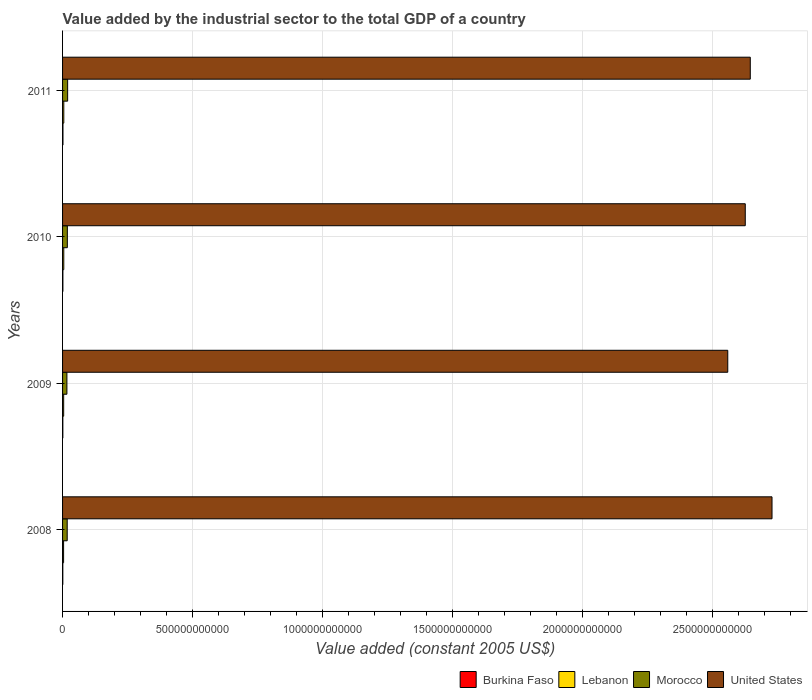How many different coloured bars are there?
Offer a terse response. 4. How many groups of bars are there?
Your answer should be very brief. 4. How many bars are there on the 3rd tick from the top?
Keep it short and to the point. 4. What is the label of the 4th group of bars from the top?
Your response must be concise. 2008. What is the value added by the industrial sector in Morocco in 2009?
Your answer should be compact. 1.67e+1. Across all years, what is the maximum value added by the industrial sector in Burkina Faso?
Keep it short and to the point. 1.52e+09. Across all years, what is the minimum value added by the industrial sector in United States?
Offer a terse response. 2.56e+12. In which year was the value added by the industrial sector in Burkina Faso maximum?
Your answer should be very brief. 2011. What is the total value added by the industrial sector in United States in the graph?
Your response must be concise. 1.06e+13. What is the difference between the value added by the industrial sector in Lebanon in 2008 and that in 2009?
Your response must be concise. -3.20e+08. What is the difference between the value added by the industrial sector in Lebanon in 2010 and the value added by the industrial sector in Burkina Faso in 2011?
Your answer should be compact. 3.13e+09. What is the average value added by the industrial sector in Lebanon per year?
Your answer should be very brief. 4.40e+09. In the year 2008, what is the difference between the value added by the industrial sector in United States and value added by the industrial sector in Burkina Faso?
Ensure brevity in your answer.  2.73e+12. What is the ratio of the value added by the industrial sector in Burkina Faso in 2008 to that in 2010?
Give a very brief answer. 0.78. Is the value added by the industrial sector in United States in 2008 less than that in 2010?
Your answer should be very brief. No. Is the difference between the value added by the industrial sector in United States in 2008 and 2010 greater than the difference between the value added by the industrial sector in Burkina Faso in 2008 and 2010?
Your answer should be compact. Yes. What is the difference between the highest and the second highest value added by the industrial sector in Burkina Faso?
Provide a succinct answer. 2.94e+08. What is the difference between the highest and the lowest value added by the industrial sector in United States?
Offer a terse response. 1.70e+11. Is the sum of the value added by the industrial sector in Morocco in 2008 and 2009 greater than the maximum value added by the industrial sector in Burkina Faso across all years?
Your answer should be very brief. Yes. What does the 3rd bar from the top in 2010 represents?
Ensure brevity in your answer.  Lebanon. What does the 1st bar from the bottom in 2010 represents?
Provide a short and direct response. Burkina Faso. How many years are there in the graph?
Give a very brief answer. 4. What is the difference between two consecutive major ticks on the X-axis?
Provide a short and direct response. 5.00e+11. Does the graph contain grids?
Keep it short and to the point. Yes. Where does the legend appear in the graph?
Give a very brief answer. Bottom right. What is the title of the graph?
Your response must be concise. Value added by the industrial sector to the total GDP of a country. Does "Korea (Democratic)" appear as one of the legend labels in the graph?
Your response must be concise. No. What is the label or title of the X-axis?
Make the answer very short. Value added (constant 2005 US$). What is the Value added (constant 2005 US$) in Burkina Faso in 2008?
Your answer should be very brief. 9.61e+08. What is the Value added (constant 2005 US$) in Lebanon in 2008?
Your response must be concise. 3.95e+09. What is the Value added (constant 2005 US$) of Morocco in 2008?
Make the answer very short. 1.78e+1. What is the Value added (constant 2005 US$) in United States in 2008?
Offer a terse response. 2.73e+12. What is the Value added (constant 2005 US$) of Burkina Faso in 2009?
Keep it short and to the point. 1.08e+09. What is the Value added (constant 2005 US$) in Lebanon in 2009?
Offer a terse response. 4.27e+09. What is the Value added (constant 2005 US$) of Morocco in 2009?
Make the answer very short. 1.67e+1. What is the Value added (constant 2005 US$) in United States in 2009?
Ensure brevity in your answer.  2.56e+12. What is the Value added (constant 2005 US$) in Burkina Faso in 2010?
Your answer should be very brief. 1.23e+09. What is the Value added (constant 2005 US$) in Lebanon in 2010?
Keep it short and to the point. 4.65e+09. What is the Value added (constant 2005 US$) of Morocco in 2010?
Offer a terse response. 1.84e+1. What is the Value added (constant 2005 US$) of United States in 2010?
Offer a very short reply. 2.62e+12. What is the Value added (constant 2005 US$) in Burkina Faso in 2011?
Ensure brevity in your answer.  1.52e+09. What is the Value added (constant 2005 US$) in Lebanon in 2011?
Make the answer very short. 4.75e+09. What is the Value added (constant 2005 US$) in Morocco in 2011?
Make the answer very short. 1.95e+1. What is the Value added (constant 2005 US$) of United States in 2011?
Make the answer very short. 2.64e+12. Across all years, what is the maximum Value added (constant 2005 US$) of Burkina Faso?
Provide a succinct answer. 1.52e+09. Across all years, what is the maximum Value added (constant 2005 US$) of Lebanon?
Provide a short and direct response. 4.75e+09. Across all years, what is the maximum Value added (constant 2005 US$) in Morocco?
Give a very brief answer. 1.95e+1. Across all years, what is the maximum Value added (constant 2005 US$) of United States?
Ensure brevity in your answer.  2.73e+12. Across all years, what is the minimum Value added (constant 2005 US$) of Burkina Faso?
Offer a very short reply. 9.61e+08. Across all years, what is the minimum Value added (constant 2005 US$) in Lebanon?
Give a very brief answer. 3.95e+09. Across all years, what is the minimum Value added (constant 2005 US$) of Morocco?
Provide a short and direct response. 1.67e+1. Across all years, what is the minimum Value added (constant 2005 US$) in United States?
Offer a very short reply. 2.56e+12. What is the total Value added (constant 2005 US$) in Burkina Faso in the graph?
Your answer should be very brief. 4.80e+09. What is the total Value added (constant 2005 US$) in Lebanon in the graph?
Your response must be concise. 1.76e+1. What is the total Value added (constant 2005 US$) in Morocco in the graph?
Keep it short and to the point. 7.24e+1. What is the total Value added (constant 2005 US$) in United States in the graph?
Ensure brevity in your answer.  1.06e+13. What is the difference between the Value added (constant 2005 US$) in Burkina Faso in 2008 and that in 2009?
Give a very brief answer. -1.23e+08. What is the difference between the Value added (constant 2005 US$) of Lebanon in 2008 and that in 2009?
Provide a succinct answer. -3.20e+08. What is the difference between the Value added (constant 2005 US$) of Morocco in 2008 and that in 2009?
Offer a terse response. 1.17e+09. What is the difference between the Value added (constant 2005 US$) in United States in 2008 and that in 2009?
Provide a short and direct response. 1.70e+11. What is the difference between the Value added (constant 2005 US$) of Burkina Faso in 2008 and that in 2010?
Keep it short and to the point. -2.68e+08. What is the difference between the Value added (constant 2005 US$) of Lebanon in 2008 and that in 2010?
Provide a succinct answer. -7.02e+08. What is the difference between the Value added (constant 2005 US$) in Morocco in 2008 and that in 2010?
Ensure brevity in your answer.  -5.33e+08. What is the difference between the Value added (constant 2005 US$) in United States in 2008 and that in 2010?
Your answer should be compact. 1.03e+11. What is the difference between the Value added (constant 2005 US$) of Burkina Faso in 2008 and that in 2011?
Offer a very short reply. -5.62e+08. What is the difference between the Value added (constant 2005 US$) in Lebanon in 2008 and that in 2011?
Keep it short and to the point. -7.96e+08. What is the difference between the Value added (constant 2005 US$) of Morocco in 2008 and that in 2011?
Provide a succinct answer. -1.69e+09. What is the difference between the Value added (constant 2005 US$) of United States in 2008 and that in 2011?
Provide a succinct answer. 8.36e+1. What is the difference between the Value added (constant 2005 US$) in Burkina Faso in 2009 and that in 2010?
Make the answer very short. -1.45e+08. What is the difference between the Value added (constant 2005 US$) of Lebanon in 2009 and that in 2010?
Your answer should be compact. -3.82e+08. What is the difference between the Value added (constant 2005 US$) of Morocco in 2009 and that in 2010?
Offer a terse response. -1.71e+09. What is the difference between the Value added (constant 2005 US$) in United States in 2009 and that in 2010?
Provide a short and direct response. -6.73e+1. What is the difference between the Value added (constant 2005 US$) in Burkina Faso in 2009 and that in 2011?
Give a very brief answer. -4.38e+08. What is the difference between the Value added (constant 2005 US$) of Lebanon in 2009 and that in 2011?
Your answer should be compact. -4.75e+08. What is the difference between the Value added (constant 2005 US$) in Morocco in 2009 and that in 2011?
Your response must be concise. -2.86e+09. What is the difference between the Value added (constant 2005 US$) of United States in 2009 and that in 2011?
Provide a short and direct response. -8.66e+1. What is the difference between the Value added (constant 2005 US$) of Burkina Faso in 2010 and that in 2011?
Offer a very short reply. -2.94e+08. What is the difference between the Value added (constant 2005 US$) of Lebanon in 2010 and that in 2011?
Your answer should be very brief. -9.35e+07. What is the difference between the Value added (constant 2005 US$) in Morocco in 2010 and that in 2011?
Provide a short and direct response. -1.16e+09. What is the difference between the Value added (constant 2005 US$) of United States in 2010 and that in 2011?
Provide a succinct answer. -1.93e+1. What is the difference between the Value added (constant 2005 US$) of Burkina Faso in 2008 and the Value added (constant 2005 US$) of Lebanon in 2009?
Give a very brief answer. -3.31e+09. What is the difference between the Value added (constant 2005 US$) in Burkina Faso in 2008 and the Value added (constant 2005 US$) in Morocco in 2009?
Keep it short and to the point. -1.57e+1. What is the difference between the Value added (constant 2005 US$) of Burkina Faso in 2008 and the Value added (constant 2005 US$) of United States in 2009?
Your response must be concise. -2.56e+12. What is the difference between the Value added (constant 2005 US$) of Lebanon in 2008 and the Value added (constant 2005 US$) of Morocco in 2009?
Provide a short and direct response. -1.27e+1. What is the difference between the Value added (constant 2005 US$) in Lebanon in 2008 and the Value added (constant 2005 US$) in United States in 2009?
Keep it short and to the point. -2.55e+12. What is the difference between the Value added (constant 2005 US$) in Morocco in 2008 and the Value added (constant 2005 US$) in United States in 2009?
Provide a short and direct response. -2.54e+12. What is the difference between the Value added (constant 2005 US$) of Burkina Faso in 2008 and the Value added (constant 2005 US$) of Lebanon in 2010?
Provide a short and direct response. -3.69e+09. What is the difference between the Value added (constant 2005 US$) of Burkina Faso in 2008 and the Value added (constant 2005 US$) of Morocco in 2010?
Your answer should be very brief. -1.74e+1. What is the difference between the Value added (constant 2005 US$) in Burkina Faso in 2008 and the Value added (constant 2005 US$) in United States in 2010?
Your response must be concise. -2.62e+12. What is the difference between the Value added (constant 2005 US$) of Lebanon in 2008 and the Value added (constant 2005 US$) of Morocco in 2010?
Ensure brevity in your answer.  -1.44e+1. What is the difference between the Value added (constant 2005 US$) of Lebanon in 2008 and the Value added (constant 2005 US$) of United States in 2010?
Give a very brief answer. -2.62e+12. What is the difference between the Value added (constant 2005 US$) of Morocco in 2008 and the Value added (constant 2005 US$) of United States in 2010?
Make the answer very short. -2.61e+12. What is the difference between the Value added (constant 2005 US$) in Burkina Faso in 2008 and the Value added (constant 2005 US$) in Lebanon in 2011?
Your response must be concise. -3.78e+09. What is the difference between the Value added (constant 2005 US$) of Burkina Faso in 2008 and the Value added (constant 2005 US$) of Morocco in 2011?
Offer a very short reply. -1.86e+1. What is the difference between the Value added (constant 2005 US$) in Burkina Faso in 2008 and the Value added (constant 2005 US$) in United States in 2011?
Your response must be concise. -2.64e+12. What is the difference between the Value added (constant 2005 US$) of Lebanon in 2008 and the Value added (constant 2005 US$) of Morocco in 2011?
Keep it short and to the point. -1.56e+1. What is the difference between the Value added (constant 2005 US$) of Lebanon in 2008 and the Value added (constant 2005 US$) of United States in 2011?
Offer a terse response. -2.64e+12. What is the difference between the Value added (constant 2005 US$) in Morocco in 2008 and the Value added (constant 2005 US$) in United States in 2011?
Your answer should be compact. -2.63e+12. What is the difference between the Value added (constant 2005 US$) in Burkina Faso in 2009 and the Value added (constant 2005 US$) in Lebanon in 2010?
Provide a succinct answer. -3.57e+09. What is the difference between the Value added (constant 2005 US$) in Burkina Faso in 2009 and the Value added (constant 2005 US$) in Morocco in 2010?
Ensure brevity in your answer.  -1.73e+1. What is the difference between the Value added (constant 2005 US$) in Burkina Faso in 2009 and the Value added (constant 2005 US$) in United States in 2010?
Offer a terse response. -2.62e+12. What is the difference between the Value added (constant 2005 US$) of Lebanon in 2009 and the Value added (constant 2005 US$) of Morocco in 2010?
Your response must be concise. -1.41e+1. What is the difference between the Value added (constant 2005 US$) of Lebanon in 2009 and the Value added (constant 2005 US$) of United States in 2010?
Give a very brief answer. -2.62e+12. What is the difference between the Value added (constant 2005 US$) of Morocco in 2009 and the Value added (constant 2005 US$) of United States in 2010?
Ensure brevity in your answer.  -2.61e+12. What is the difference between the Value added (constant 2005 US$) in Burkina Faso in 2009 and the Value added (constant 2005 US$) in Lebanon in 2011?
Offer a terse response. -3.66e+09. What is the difference between the Value added (constant 2005 US$) in Burkina Faso in 2009 and the Value added (constant 2005 US$) in Morocco in 2011?
Your answer should be compact. -1.84e+1. What is the difference between the Value added (constant 2005 US$) in Burkina Faso in 2009 and the Value added (constant 2005 US$) in United States in 2011?
Make the answer very short. -2.64e+12. What is the difference between the Value added (constant 2005 US$) of Lebanon in 2009 and the Value added (constant 2005 US$) of Morocco in 2011?
Your response must be concise. -1.53e+1. What is the difference between the Value added (constant 2005 US$) in Lebanon in 2009 and the Value added (constant 2005 US$) in United States in 2011?
Ensure brevity in your answer.  -2.64e+12. What is the difference between the Value added (constant 2005 US$) of Morocco in 2009 and the Value added (constant 2005 US$) of United States in 2011?
Your answer should be compact. -2.63e+12. What is the difference between the Value added (constant 2005 US$) in Burkina Faso in 2010 and the Value added (constant 2005 US$) in Lebanon in 2011?
Offer a terse response. -3.52e+09. What is the difference between the Value added (constant 2005 US$) of Burkina Faso in 2010 and the Value added (constant 2005 US$) of Morocco in 2011?
Give a very brief answer. -1.83e+1. What is the difference between the Value added (constant 2005 US$) in Burkina Faso in 2010 and the Value added (constant 2005 US$) in United States in 2011?
Give a very brief answer. -2.64e+12. What is the difference between the Value added (constant 2005 US$) of Lebanon in 2010 and the Value added (constant 2005 US$) of Morocco in 2011?
Provide a succinct answer. -1.49e+1. What is the difference between the Value added (constant 2005 US$) of Lebanon in 2010 and the Value added (constant 2005 US$) of United States in 2011?
Provide a succinct answer. -2.64e+12. What is the difference between the Value added (constant 2005 US$) in Morocco in 2010 and the Value added (constant 2005 US$) in United States in 2011?
Offer a terse response. -2.63e+12. What is the average Value added (constant 2005 US$) of Burkina Faso per year?
Make the answer very short. 1.20e+09. What is the average Value added (constant 2005 US$) of Lebanon per year?
Provide a succinct answer. 4.40e+09. What is the average Value added (constant 2005 US$) in Morocco per year?
Offer a terse response. 1.81e+1. What is the average Value added (constant 2005 US$) of United States per year?
Your answer should be compact. 2.64e+12. In the year 2008, what is the difference between the Value added (constant 2005 US$) of Burkina Faso and Value added (constant 2005 US$) of Lebanon?
Ensure brevity in your answer.  -2.99e+09. In the year 2008, what is the difference between the Value added (constant 2005 US$) of Burkina Faso and Value added (constant 2005 US$) of Morocco?
Your answer should be compact. -1.69e+1. In the year 2008, what is the difference between the Value added (constant 2005 US$) in Burkina Faso and Value added (constant 2005 US$) in United States?
Offer a terse response. -2.73e+12. In the year 2008, what is the difference between the Value added (constant 2005 US$) in Lebanon and Value added (constant 2005 US$) in Morocco?
Your answer should be very brief. -1.39e+1. In the year 2008, what is the difference between the Value added (constant 2005 US$) in Lebanon and Value added (constant 2005 US$) in United States?
Make the answer very short. -2.72e+12. In the year 2008, what is the difference between the Value added (constant 2005 US$) of Morocco and Value added (constant 2005 US$) of United States?
Offer a terse response. -2.71e+12. In the year 2009, what is the difference between the Value added (constant 2005 US$) in Burkina Faso and Value added (constant 2005 US$) in Lebanon?
Offer a terse response. -3.19e+09. In the year 2009, what is the difference between the Value added (constant 2005 US$) of Burkina Faso and Value added (constant 2005 US$) of Morocco?
Make the answer very short. -1.56e+1. In the year 2009, what is the difference between the Value added (constant 2005 US$) in Burkina Faso and Value added (constant 2005 US$) in United States?
Offer a very short reply. -2.56e+12. In the year 2009, what is the difference between the Value added (constant 2005 US$) in Lebanon and Value added (constant 2005 US$) in Morocco?
Make the answer very short. -1.24e+1. In the year 2009, what is the difference between the Value added (constant 2005 US$) in Lebanon and Value added (constant 2005 US$) in United States?
Give a very brief answer. -2.55e+12. In the year 2009, what is the difference between the Value added (constant 2005 US$) in Morocco and Value added (constant 2005 US$) in United States?
Your answer should be compact. -2.54e+12. In the year 2010, what is the difference between the Value added (constant 2005 US$) of Burkina Faso and Value added (constant 2005 US$) of Lebanon?
Your answer should be compact. -3.42e+09. In the year 2010, what is the difference between the Value added (constant 2005 US$) in Burkina Faso and Value added (constant 2005 US$) in Morocco?
Offer a very short reply. -1.71e+1. In the year 2010, what is the difference between the Value added (constant 2005 US$) of Burkina Faso and Value added (constant 2005 US$) of United States?
Your answer should be very brief. -2.62e+12. In the year 2010, what is the difference between the Value added (constant 2005 US$) in Lebanon and Value added (constant 2005 US$) in Morocco?
Your answer should be compact. -1.37e+1. In the year 2010, what is the difference between the Value added (constant 2005 US$) in Lebanon and Value added (constant 2005 US$) in United States?
Provide a short and direct response. -2.62e+12. In the year 2010, what is the difference between the Value added (constant 2005 US$) of Morocco and Value added (constant 2005 US$) of United States?
Your answer should be compact. -2.61e+12. In the year 2011, what is the difference between the Value added (constant 2005 US$) of Burkina Faso and Value added (constant 2005 US$) of Lebanon?
Offer a very short reply. -3.22e+09. In the year 2011, what is the difference between the Value added (constant 2005 US$) in Burkina Faso and Value added (constant 2005 US$) in Morocco?
Provide a short and direct response. -1.80e+1. In the year 2011, what is the difference between the Value added (constant 2005 US$) in Burkina Faso and Value added (constant 2005 US$) in United States?
Offer a terse response. -2.64e+12. In the year 2011, what is the difference between the Value added (constant 2005 US$) of Lebanon and Value added (constant 2005 US$) of Morocco?
Provide a succinct answer. -1.48e+1. In the year 2011, what is the difference between the Value added (constant 2005 US$) of Lebanon and Value added (constant 2005 US$) of United States?
Make the answer very short. -2.64e+12. In the year 2011, what is the difference between the Value added (constant 2005 US$) of Morocco and Value added (constant 2005 US$) of United States?
Keep it short and to the point. -2.62e+12. What is the ratio of the Value added (constant 2005 US$) in Burkina Faso in 2008 to that in 2009?
Ensure brevity in your answer.  0.89. What is the ratio of the Value added (constant 2005 US$) in Lebanon in 2008 to that in 2009?
Offer a very short reply. 0.93. What is the ratio of the Value added (constant 2005 US$) in Morocco in 2008 to that in 2009?
Ensure brevity in your answer.  1.07. What is the ratio of the Value added (constant 2005 US$) in United States in 2008 to that in 2009?
Give a very brief answer. 1.07. What is the ratio of the Value added (constant 2005 US$) of Burkina Faso in 2008 to that in 2010?
Your answer should be very brief. 0.78. What is the ratio of the Value added (constant 2005 US$) of Lebanon in 2008 to that in 2010?
Keep it short and to the point. 0.85. What is the ratio of the Value added (constant 2005 US$) in United States in 2008 to that in 2010?
Give a very brief answer. 1.04. What is the ratio of the Value added (constant 2005 US$) of Burkina Faso in 2008 to that in 2011?
Your answer should be compact. 0.63. What is the ratio of the Value added (constant 2005 US$) of Lebanon in 2008 to that in 2011?
Give a very brief answer. 0.83. What is the ratio of the Value added (constant 2005 US$) in Morocco in 2008 to that in 2011?
Keep it short and to the point. 0.91. What is the ratio of the Value added (constant 2005 US$) in United States in 2008 to that in 2011?
Provide a succinct answer. 1.03. What is the ratio of the Value added (constant 2005 US$) in Burkina Faso in 2009 to that in 2010?
Provide a succinct answer. 0.88. What is the ratio of the Value added (constant 2005 US$) in Lebanon in 2009 to that in 2010?
Provide a succinct answer. 0.92. What is the ratio of the Value added (constant 2005 US$) in Morocco in 2009 to that in 2010?
Offer a very short reply. 0.91. What is the ratio of the Value added (constant 2005 US$) of United States in 2009 to that in 2010?
Keep it short and to the point. 0.97. What is the ratio of the Value added (constant 2005 US$) in Burkina Faso in 2009 to that in 2011?
Provide a succinct answer. 0.71. What is the ratio of the Value added (constant 2005 US$) of Lebanon in 2009 to that in 2011?
Your answer should be very brief. 0.9. What is the ratio of the Value added (constant 2005 US$) of Morocco in 2009 to that in 2011?
Offer a terse response. 0.85. What is the ratio of the Value added (constant 2005 US$) of United States in 2009 to that in 2011?
Provide a succinct answer. 0.97. What is the ratio of the Value added (constant 2005 US$) of Burkina Faso in 2010 to that in 2011?
Your response must be concise. 0.81. What is the ratio of the Value added (constant 2005 US$) of Lebanon in 2010 to that in 2011?
Your answer should be compact. 0.98. What is the ratio of the Value added (constant 2005 US$) in Morocco in 2010 to that in 2011?
Make the answer very short. 0.94. What is the ratio of the Value added (constant 2005 US$) in United States in 2010 to that in 2011?
Make the answer very short. 0.99. What is the difference between the highest and the second highest Value added (constant 2005 US$) in Burkina Faso?
Offer a very short reply. 2.94e+08. What is the difference between the highest and the second highest Value added (constant 2005 US$) of Lebanon?
Make the answer very short. 9.35e+07. What is the difference between the highest and the second highest Value added (constant 2005 US$) of Morocco?
Your response must be concise. 1.16e+09. What is the difference between the highest and the second highest Value added (constant 2005 US$) in United States?
Your response must be concise. 8.36e+1. What is the difference between the highest and the lowest Value added (constant 2005 US$) of Burkina Faso?
Your answer should be compact. 5.62e+08. What is the difference between the highest and the lowest Value added (constant 2005 US$) in Lebanon?
Provide a short and direct response. 7.96e+08. What is the difference between the highest and the lowest Value added (constant 2005 US$) in Morocco?
Provide a short and direct response. 2.86e+09. What is the difference between the highest and the lowest Value added (constant 2005 US$) of United States?
Offer a terse response. 1.70e+11. 